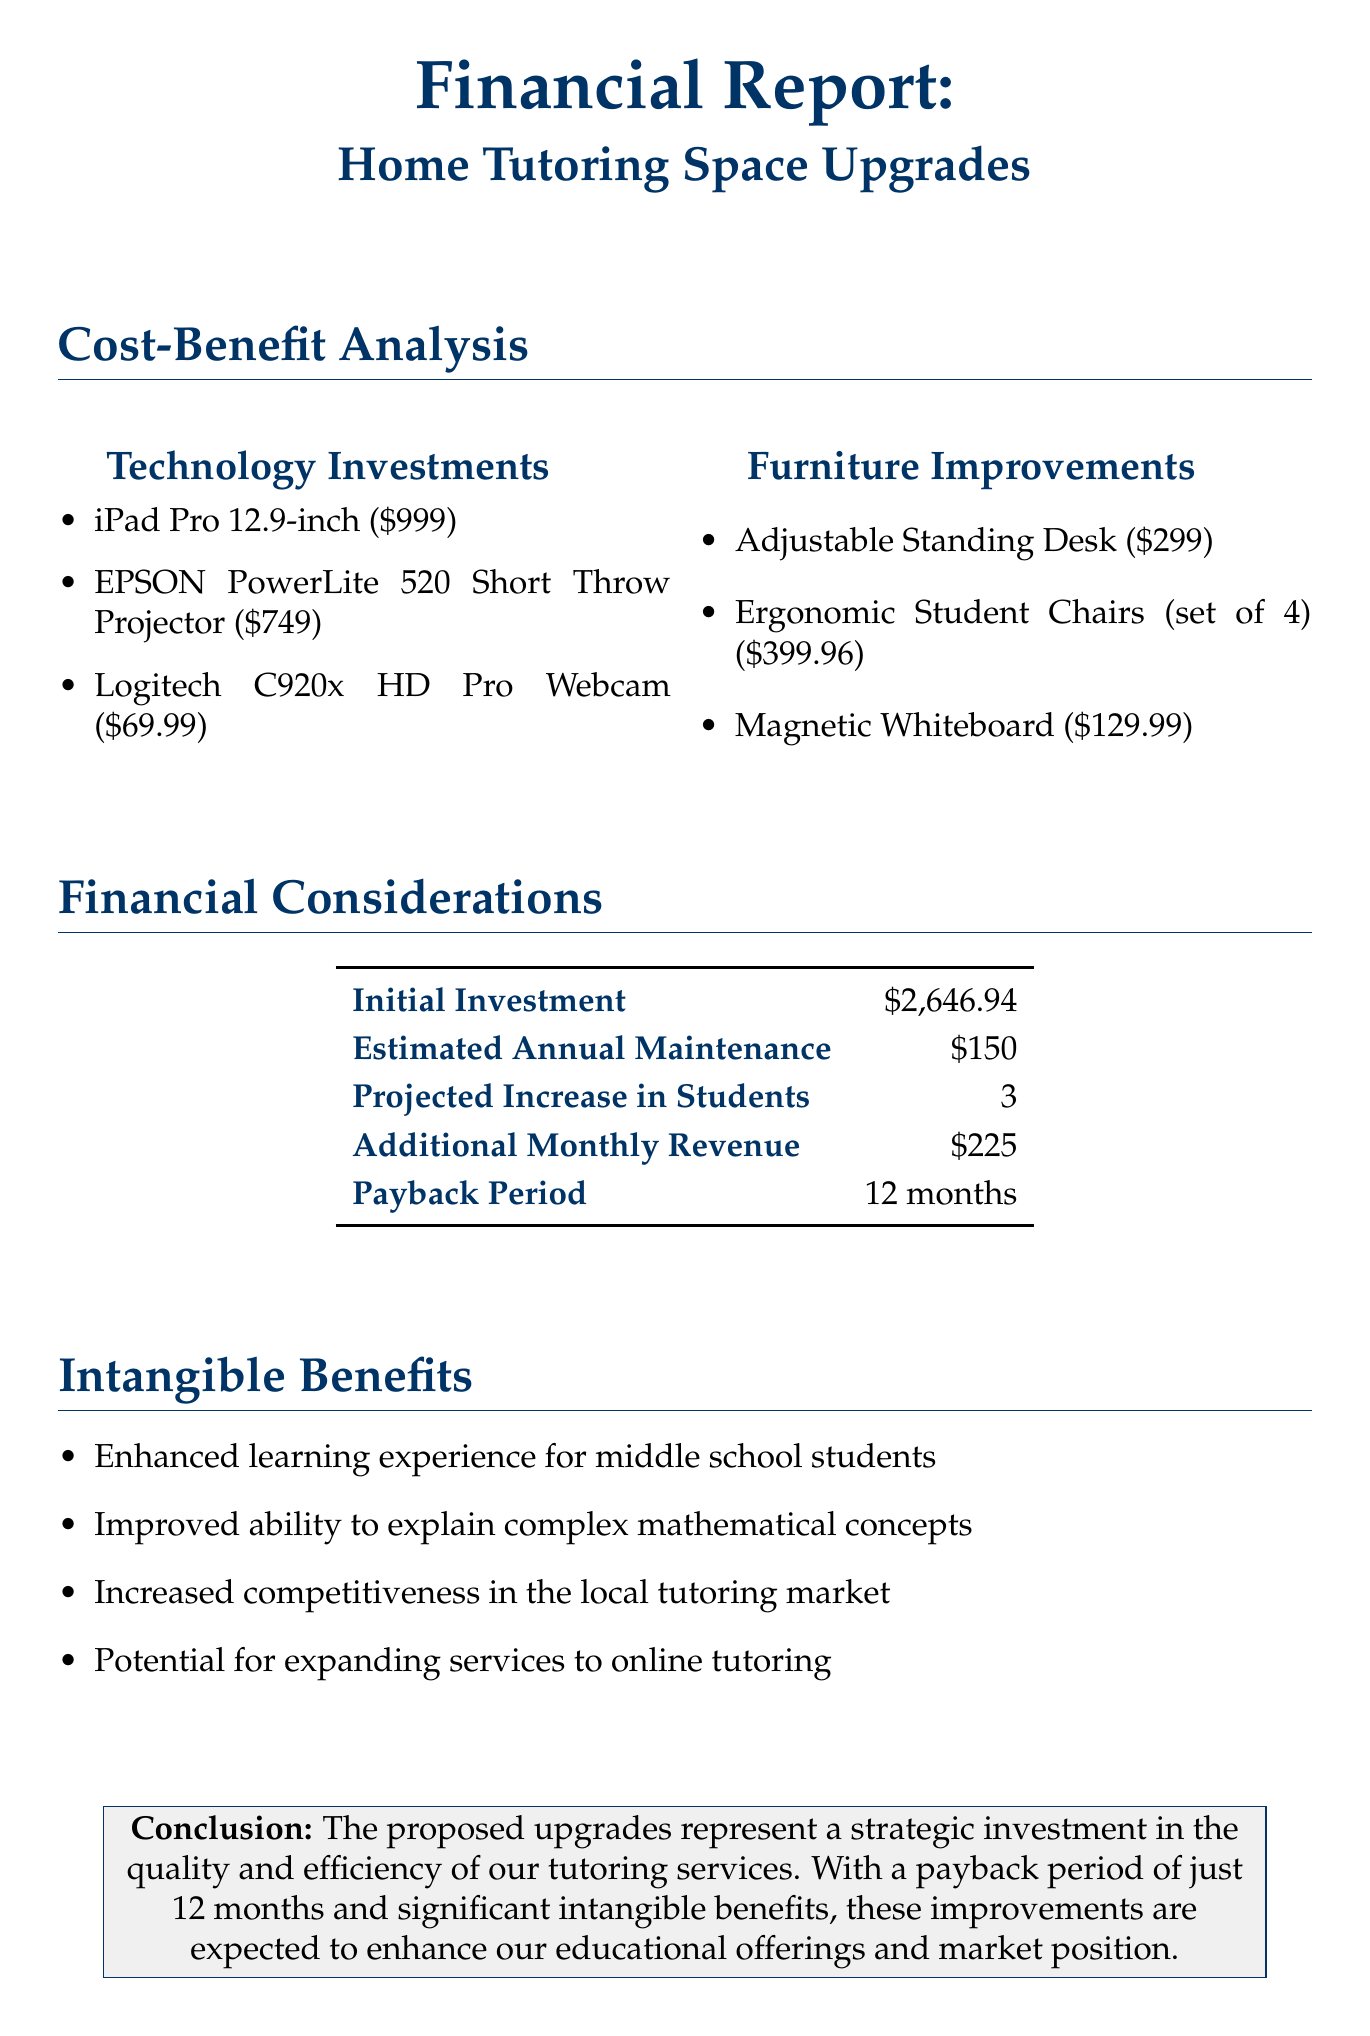What is the total initial investment for the upgrades? The total initial investment is listed in the financial considerations section of the document.
Answer: $2,646.94 How many additional students are projected to enroll after upgrades? The projected increase in students is mentioned in the financial considerations section of the document.
Answer: 3 What item is suggested for improving visual presentations? The item that improves visual presentations is specifically detailed in the technology investments section.
Answer: EPSON PowerLite 520 Short Throw Projector What is the cost of the ergonomic student chairs? The cost of the ergonomic student chairs is provided in the furniture improvements section.
Answer: $399.96 What is the estimated annual maintenance cost? The estimated annual maintenance cost is provided in the financial considerations section of the document.
Answer: $150 Which benefit relates to expanding services? The intangible benefit that relates to expanding services is explicitly mentioned in the list of intangible benefits.
Answer: Potential for expanding services to online tutoring How long is the payback period for the investment? The payback period information is found in the financial considerations section of the report.
Answer: 12 months What technology item serves as a high-quality video resource? This technology item is indicated in the technology investments for remote sessions.
Answer: Logitech C920x HD Pro Webcam What is the benefit of the adjustable standing desk? The benefit of the adjustable standing desk is highlighted in the furniture improvements section.
Answer: Versatile workspace for different student heights and learning styles 